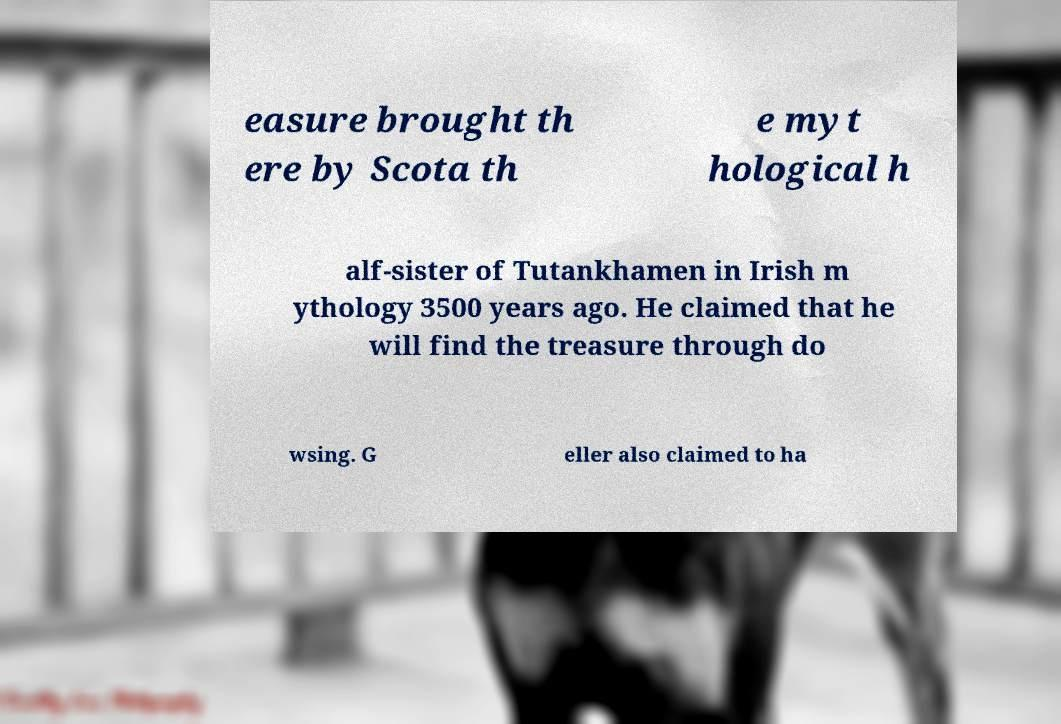Can you accurately transcribe the text from the provided image for me? easure brought th ere by Scota th e myt hological h alf-sister of Tutankhamen in Irish m ythology 3500 years ago. He claimed that he will find the treasure through do wsing. G eller also claimed to ha 